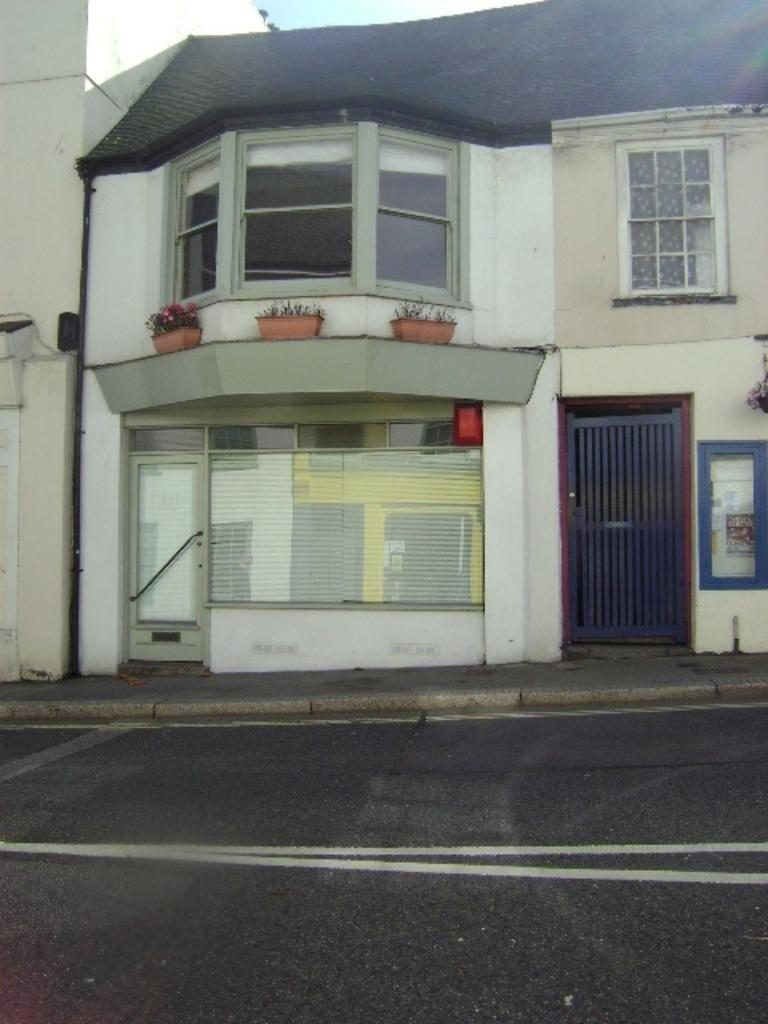What type of structure is present in the image? There is a building in the image. What feature can be seen on the building? The building has windows. What is growing near the building? There are flowers on the plants. How are the plants arranged? The plants are kept in pots. What else can be seen in the image? There is a road visible in the image. What type of development is taking place on the building in the image? There is no indication of any development or construction happening on the building in the image. What impulse might the flowers have in the image? Flowers do not have impulses or emotions, so this question cannot be answered. 